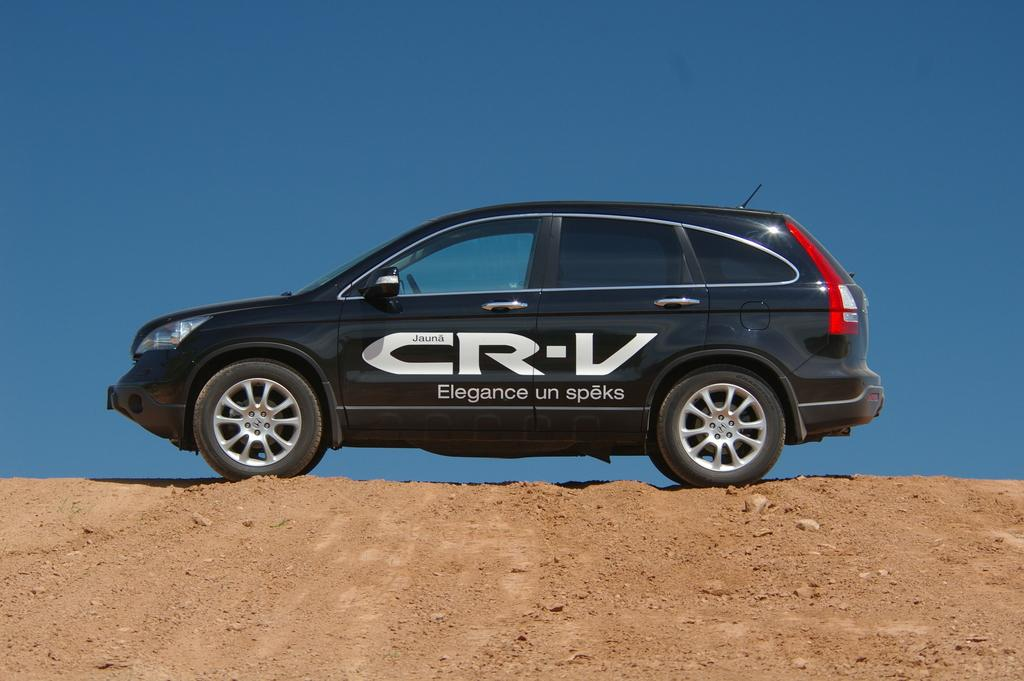What is the main subject of the image? The main subject of the image is a car. What is the condition of the surface the car is on? The car is on a mud surface. What is the color of the car? The car is black in color. What is written on the car? The car has the name "CR-V" on it. What is visible in the background of the image? The sky is visible in the image. What is the color of the sky? The sky is blue in color. Can you see a doll playing with a finger in the image? There is no doll or finger present in the image; it features a car on a mud surface with a blue sky in the background. 